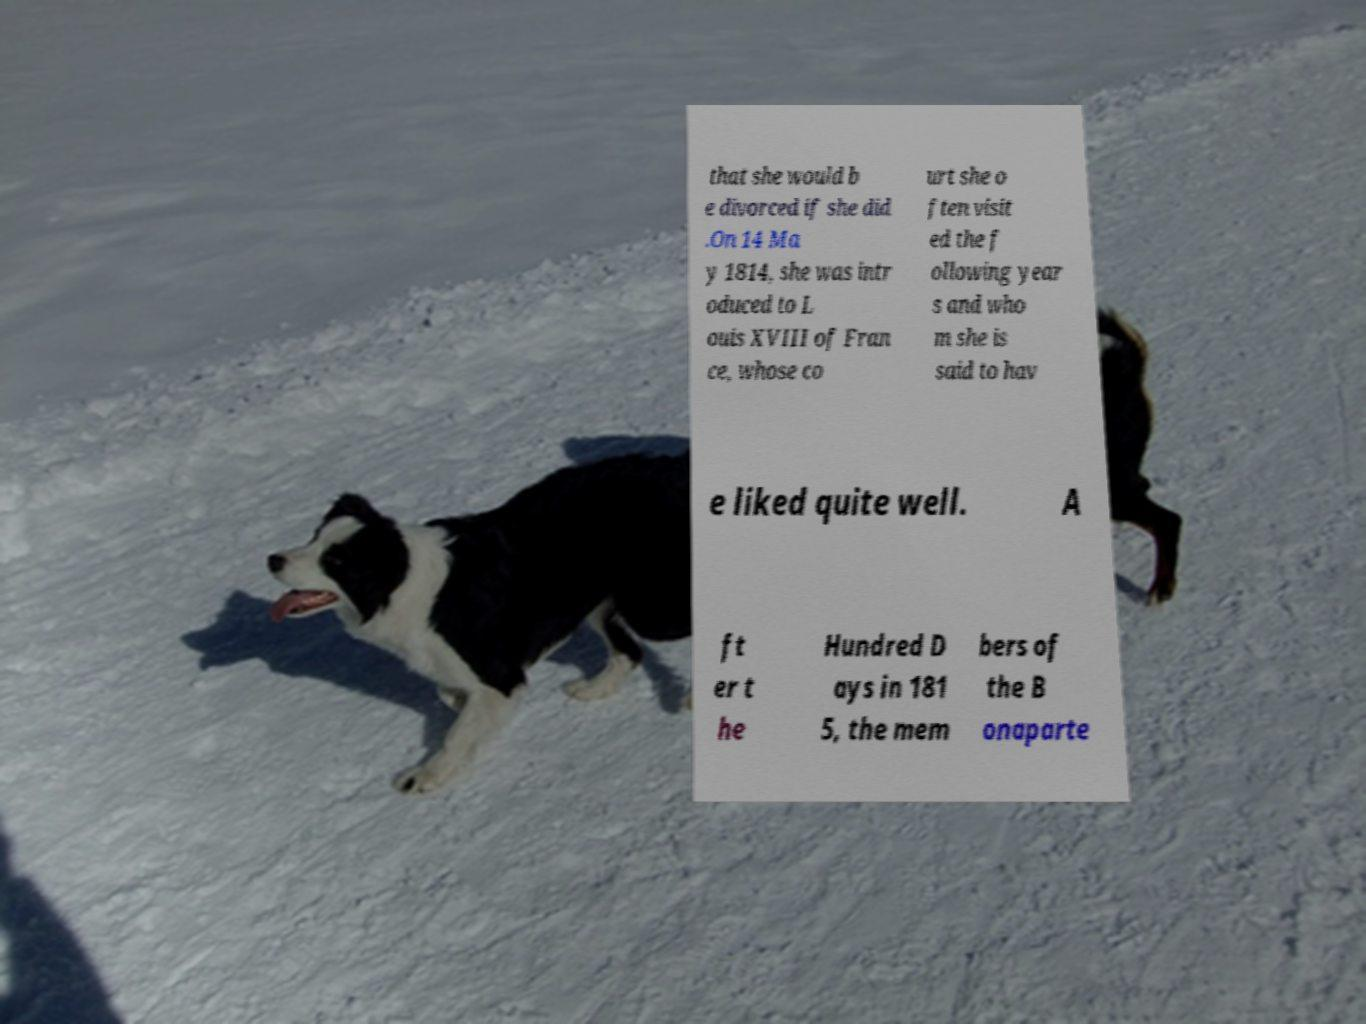I need the written content from this picture converted into text. Can you do that? that she would b e divorced if she did .On 14 Ma y 1814, she was intr oduced to L ouis XVIII of Fran ce, whose co urt she o ften visit ed the f ollowing year s and who m she is said to hav e liked quite well. A ft er t he Hundred D ays in 181 5, the mem bers of the B onaparte 